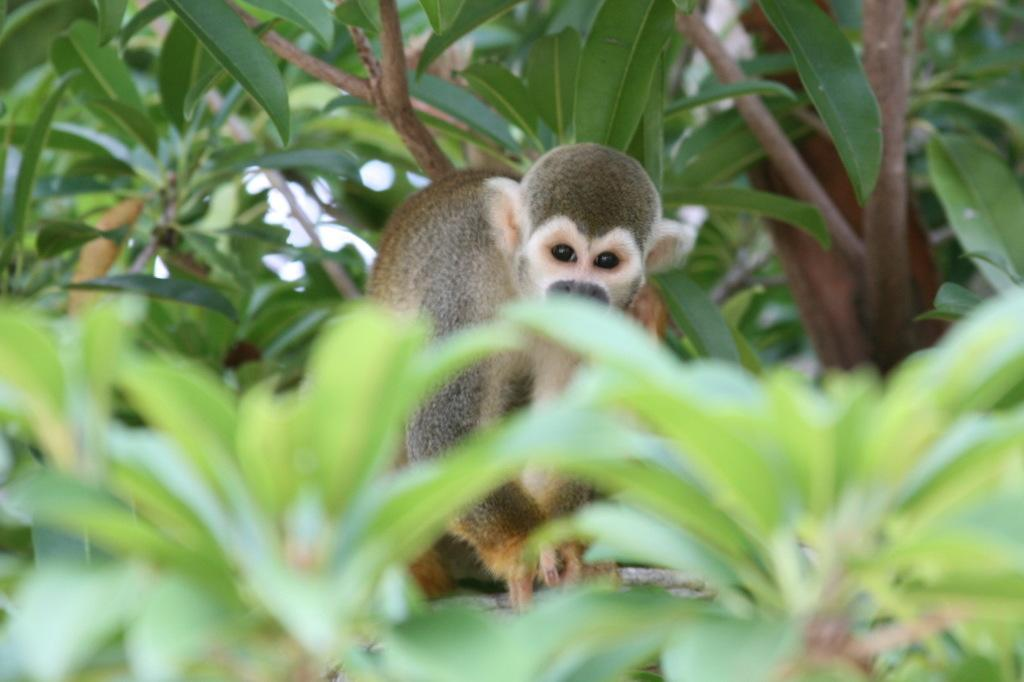What animal is present in the image? There is a monkey in the image. Where is the monkey located? The monkey is on a tree. Can you describe the position of the tree in the image? The tree is in the center of the image. What type of art can be seen hanging on the tree in the image? There is no art present in the image; it features a monkey on a tree. 